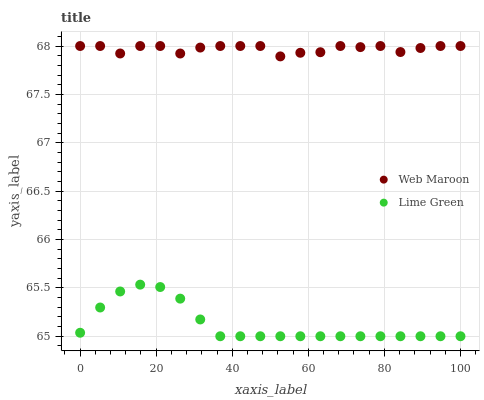Does Lime Green have the minimum area under the curve?
Answer yes or no. Yes. Does Web Maroon have the maximum area under the curve?
Answer yes or no. Yes. Does Web Maroon have the minimum area under the curve?
Answer yes or no. No. Is Lime Green the smoothest?
Answer yes or no. Yes. Is Web Maroon the roughest?
Answer yes or no. Yes. Is Web Maroon the smoothest?
Answer yes or no. No. Does Lime Green have the lowest value?
Answer yes or no. Yes. Does Web Maroon have the lowest value?
Answer yes or no. No. Does Web Maroon have the highest value?
Answer yes or no. Yes. Is Lime Green less than Web Maroon?
Answer yes or no. Yes. Is Web Maroon greater than Lime Green?
Answer yes or no. Yes. Does Lime Green intersect Web Maroon?
Answer yes or no. No. 